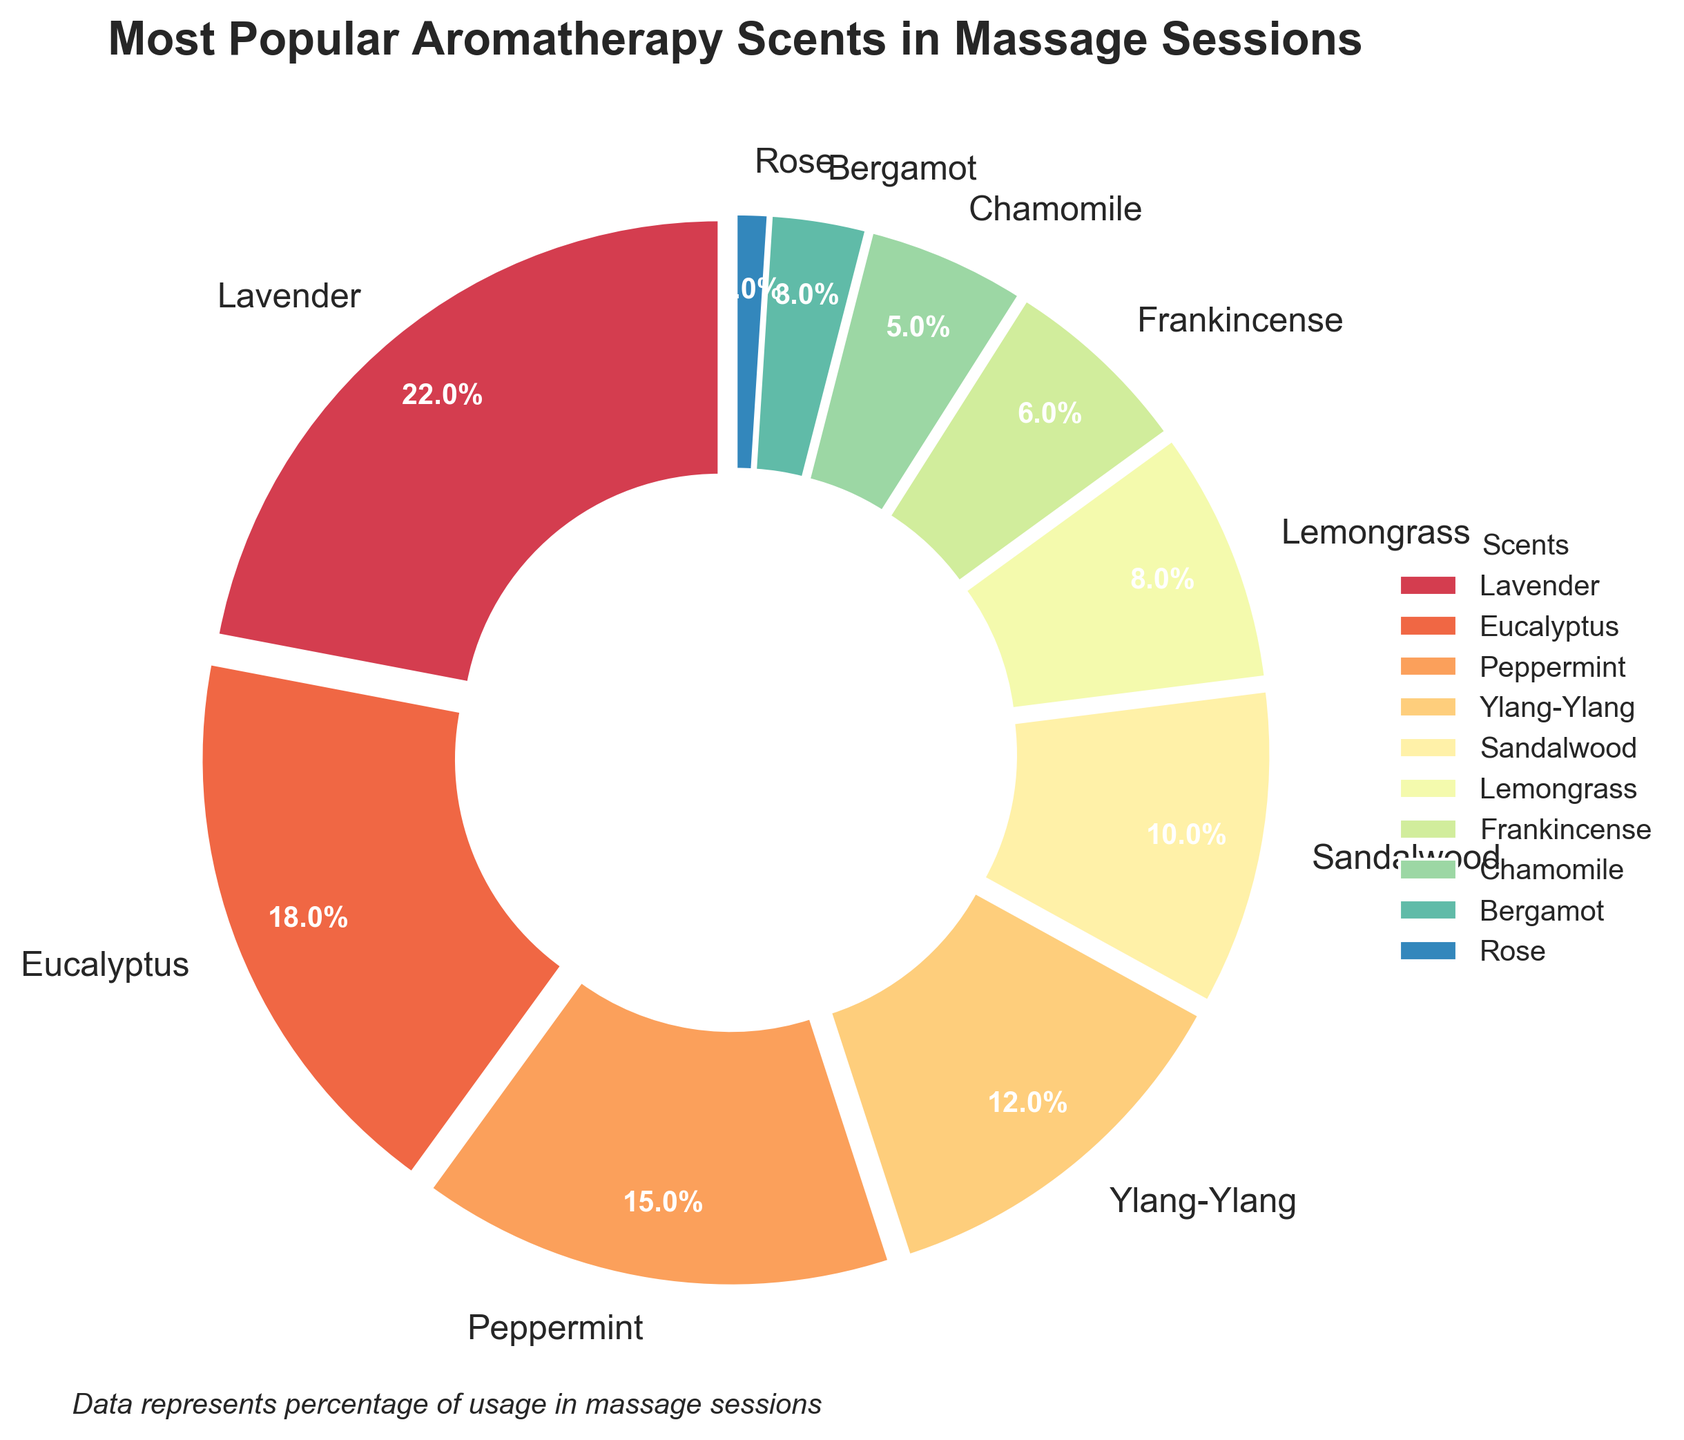What's the most popular aromatherapy scent used in massage sessions? Looking at the chart, the scent with the largest wedge and highest percentage is easily identifiable as Lavender.
Answer: Lavender Which scents have a usage percentage below 10%? By observing the figure, the scent labels with percentages lower than 10% are Sandalwood, Lemongrass, Frankincense, Chamomile, Bergamot, and Rose.
Answer: Sandalwood, Lemongrass, Frankincense, Chamomile, Bergamot, Rose Which scent has a higher usage percentage: Peppermint or Eucalyptus? By comparing the sizes of the wedges and their associated labels, Eucalyptus has a higher usage percentage (18%) compared to Peppermint (15%).
Answer: Eucalyptus What is the combined usage percentage of the least popular three scents? The least popular three scents are Rose (1%), Bergamot (3%), and Chamomile (5%). Adding these together gives 1% + 3% + 5%.
Answer: 9% What's the difference in usage percentage between the most popular and the least popular scent? The most popular scent, Lavender, has a percentage of 22%, and the least popular scent, Rose, has 1%. The difference is 22% - 1%.
Answer: 21% Which scent is closest in popularity to 10%? By glancing at the chart, the scent that has a percentage closest to 10% is Sandalwood, which exactly matches 10%.
Answer: Sandalwood What’s the average usage percentage of the top three scents? The top three scents are Lavender (22%), Eucalyptus (18%), and Peppermint (15%). To find the average: (22 + 18 + 15) / 3 = 55 / 3 = 18.3 (rounded to one decimal place).
Answer: 18.3% Is the usage percentage of Ylang-Ylang greater than the combined percentages of Frankincense and Bergamot? Ylang-Ylang is 12%, and the combined percentage of Frankincense (6%) and Bergamot (3%) is 6% + 3% = 9%. Since 12% > 9%, the answer is yes.
Answer: Yes How many scents have a usage percentage greater than or equal to 15%? Observing the figure, the scents with usage percentages equal to or greater than 15% are Lavender (22%), Eucalyptus (18%), and Peppermint (15%). There are three scents in total.
Answer: 3 